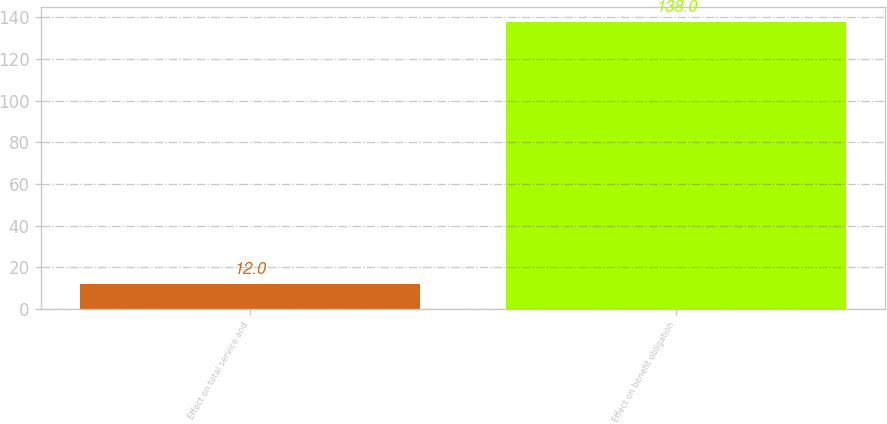<chart> <loc_0><loc_0><loc_500><loc_500><bar_chart><fcel>Effect on total service and<fcel>Effect on benefit obligation<nl><fcel>12<fcel>138<nl></chart> 